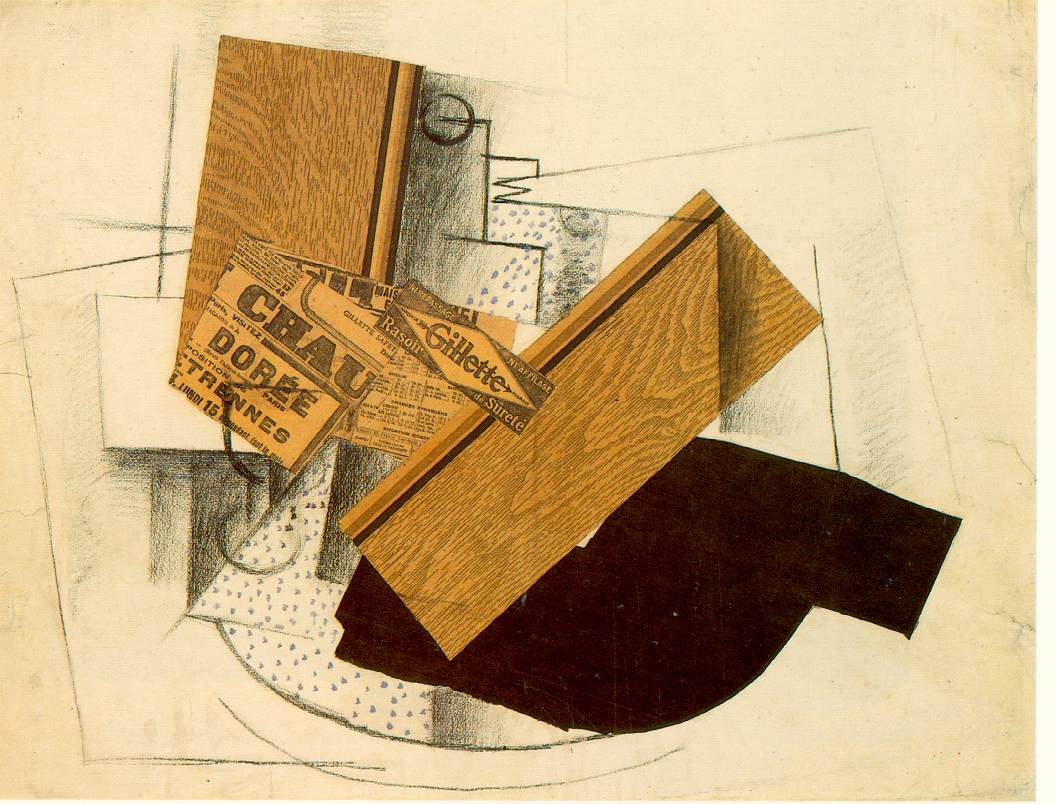Can you describe the main features of this image for me? This image is a classic example of cubist art, where abstraction and geometric forms play a pivotal role. The artwork features three primary elements that are intricately composed to challenge conventional perceptions of depth and perspective. Firstly, the element with a wooden texture forms a dynamic 'Z' shape, adding a three-dimensional feel against the otherwise flat backdrop. This texture not only enriches the visual depth but also possibly symbolizes the blending of organic and synthetic realities in cubist art. Secondly, the newspaper clipping, which is seamlessly integrated into the composition, could represent the intersection of daily life and art, highlighting how external realities can shape artistic expression. The clipping's text, although abstract, might suggest themes relevant during the artwork's creation. Lastly, the stark black shape that cuts through the composition with its bold 'C' form adds a dramatic contrast, potentially signifying the disruptive nature of new perspectives or ideas. Together, these elements not merely construct a visually intriguing piece but also invite interpretations that delve into the interaction between art, culture, and innovation. 